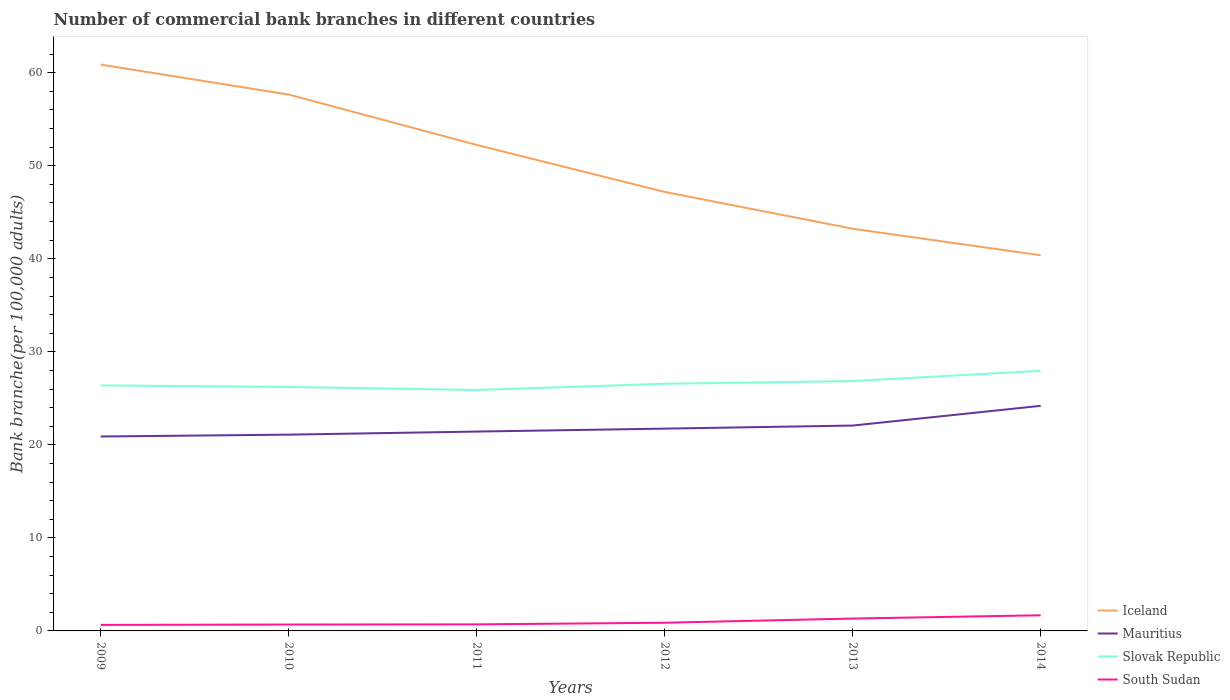How many different coloured lines are there?
Ensure brevity in your answer.  4. Does the line corresponding to Mauritius intersect with the line corresponding to Iceland?
Keep it short and to the point. No. Across all years, what is the maximum number of commercial bank branches in South Sudan?
Your answer should be very brief. 0.65. What is the total number of commercial bank branches in Iceland in the graph?
Ensure brevity in your answer.  2.85. What is the difference between the highest and the second highest number of commercial bank branches in Iceland?
Your answer should be compact. 20.5. What is the difference between the highest and the lowest number of commercial bank branches in South Sudan?
Provide a short and direct response. 2. How many lines are there?
Make the answer very short. 4. What is the difference between two consecutive major ticks on the Y-axis?
Provide a short and direct response. 10. Where does the legend appear in the graph?
Give a very brief answer. Bottom right. How many legend labels are there?
Give a very brief answer. 4. How are the legend labels stacked?
Your response must be concise. Vertical. What is the title of the graph?
Offer a terse response. Number of commercial bank branches in different countries. What is the label or title of the Y-axis?
Ensure brevity in your answer.  Bank branche(per 100,0 adults). What is the Bank branche(per 100,000 adults) in Iceland in 2009?
Keep it short and to the point. 60.87. What is the Bank branche(per 100,000 adults) of Mauritius in 2009?
Your answer should be compact. 20.9. What is the Bank branche(per 100,000 adults) of Slovak Republic in 2009?
Offer a very short reply. 26.39. What is the Bank branche(per 100,000 adults) in South Sudan in 2009?
Your response must be concise. 0.65. What is the Bank branche(per 100,000 adults) in Iceland in 2010?
Ensure brevity in your answer.  57.65. What is the Bank branche(per 100,000 adults) in Mauritius in 2010?
Your response must be concise. 21.1. What is the Bank branche(per 100,000 adults) of Slovak Republic in 2010?
Provide a succinct answer. 26.22. What is the Bank branche(per 100,000 adults) in South Sudan in 2010?
Provide a succinct answer. 0.69. What is the Bank branche(per 100,000 adults) of Iceland in 2011?
Give a very brief answer. 52.24. What is the Bank branche(per 100,000 adults) in Mauritius in 2011?
Provide a short and direct response. 21.43. What is the Bank branche(per 100,000 adults) in Slovak Republic in 2011?
Keep it short and to the point. 25.9. What is the Bank branche(per 100,000 adults) in South Sudan in 2011?
Provide a short and direct response. 0.7. What is the Bank branche(per 100,000 adults) in Iceland in 2012?
Offer a very short reply. 47.19. What is the Bank branche(per 100,000 adults) in Mauritius in 2012?
Your answer should be compact. 21.74. What is the Bank branche(per 100,000 adults) of Slovak Republic in 2012?
Give a very brief answer. 26.57. What is the Bank branche(per 100,000 adults) in South Sudan in 2012?
Provide a succinct answer. 0.88. What is the Bank branche(per 100,000 adults) in Iceland in 2013?
Provide a succinct answer. 43.23. What is the Bank branche(per 100,000 adults) in Mauritius in 2013?
Keep it short and to the point. 22.08. What is the Bank branche(per 100,000 adults) in Slovak Republic in 2013?
Your answer should be very brief. 26.86. What is the Bank branche(per 100,000 adults) in South Sudan in 2013?
Keep it short and to the point. 1.33. What is the Bank branche(per 100,000 adults) in Iceland in 2014?
Provide a short and direct response. 40.38. What is the Bank branche(per 100,000 adults) in Mauritius in 2014?
Provide a succinct answer. 24.19. What is the Bank branche(per 100,000 adults) in Slovak Republic in 2014?
Give a very brief answer. 27.96. What is the Bank branche(per 100,000 adults) in South Sudan in 2014?
Provide a succinct answer. 1.68. Across all years, what is the maximum Bank branche(per 100,000 adults) of Iceland?
Provide a succinct answer. 60.87. Across all years, what is the maximum Bank branche(per 100,000 adults) of Mauritius?
Provide a succinct answer. 24.19. Across all years, what is the maximum Bank branche(per 100,000 adults) in Slovak Republic?
Give a very brief answer. 27.96. Across all years, what is the maximum Bank branche(per 100,000 adults) in South Sudan?
Your answer should be very brief. 1.68. Across all years, what is the minimum Bank branche(per 100,000 adults) of Iceland?
Provide a short and direct response. 40.38. Across all years, what is the minimum Bank branche(per 100,000 adults) in Mauritius?
Keep it short and to the point. 20.9. Across all years, what is the minimum Bank branche(per 100,000 adults) of Slovak Republic?
Offer a very short reply. 25.9. Across all years, what is the minimum Bank branche(per 100,000 adults) of South Sudan?
Offer a very short reply. 0.65. What is the total Bank branche(per 100,000 adults) in Iceland in the graph?
Offer a very short reply. 301.57. What is the total Bank branche(per 100,000 adults) in Mauritius in the graph?
Make the answer very short. 131.44. What is the total Bank branche(per 100,000 adults) in Slovak Republic in the graph?
Provide a short and direct response. 159.89. What is the total Bank branche(per 100,000 adults) of South Sudan in the graph?
Keep it short and to the point. 5.93. What is the difference between the Bank branche(per 100,000 adults) in Iceland in 2009 and that in 2010?
Provide a succinct answer. 3.22. What is the difference between the Bank branche(per 100,000 adults) in Mauritius in 2009 and that in 2010?
Your answer should be very brief. -0.2. What is the difference between the Bank branche(per 100,000 adults) of Slovak Republic in 2009 and that in 2010?
Make the answer very short. 0.17. What is the difference between the Bank branche(per 100,000 adults) of South Sudan in 2009 and that in 2010?
Your response must be concise. -0.04. What is the difference between the Bank branche(per 100,000 adults) of Iceland in 2009 and that in 2011?
Provide a succinct answer. 8.63. What is the difference between the Bank branche(per 100,000 adults) of Mauritius in 2009 and that in 2011?
Your answer should be compact. -0.53. What is the difference between the Bank branche(per 100,000 adults) in Slovak Republic in 2009 and that in 2011?
Offer a very short reply. 0.49. What is the difference between the Bank branche(per 100,000 adults) of South Sudan in 2009 and that in 2011?
Your response must be concise. -0.06. What is the difference between the Bank branche(per 100,000 adults) in Iceland in 2009 and that in 2012?
Your answer should be compact. 13.69. What is the difference between the Bank branche(per 100,000 adults) in Mauritius in 2009 and that in 2012?
Ensure brevity in your answer.  -0.85. What is the difference between the Bank branche(per 100,000 adults) in Slovak Republic in 2009 and that in 2012?
Offer a terse response. -0.17. What is the difference between the Bank branche(per 100,000 adults) of South Sudan in 2009 and that in 2012?
Your answer should be very brief. -0.23. What is the difference between the Bank branche(per 100,000 adults) in Iceland in 2009 and that in 2013?
Make the answer very short. 17.64. What is the difference between the Bank branche(per 100,000 adults) of Mauritius in 2009 and that in 2013?
Provide a short and direct response. -1.18. What is the difference between the Bank branche(per 100,000 adults) in Slovak Republic in 2009 and that in 2013?
Your response must be concise. -0.46. What is the difference between the Bank branche(per 100,000 adults) of South Sudan in 2009 and that in 2013?
Make the answer very short. -0.68. What is the difference between the Bank branche(per 100,000 adults) of Iceland in 2009 and that in 2014?
Provide a short and direct response. 20.5. What is the difference between the Bank branche(per 100,000 adults) of Mauritius in 2009 and that in 2014?
Offer a terse response. -3.3. What is the difference between the Bank branche(per 100,000 adults) of Slovak Republic in 2009 and that in 2014?
Provide a succinct answer. -1.56. What is the difference between the Bank branche(per 100,000 adults) of South Sudan in 2009 and that in 2014?
Give a very brief answer. -1.04. What is the difference between the Bank branche(per 100,000 adults) in Iceland in 2010 and that in 2011?
Make the answer very short. 5.41. What is the difference between the Bank branche(per 100,000 adults) of Mauritius in 2010 and that in 2011?
Provide a short and direct response. -0.33. What is the difference between the Bank branche(per 100,000 adults) in Slovak Republic in 2010 and that in 2011?
Provide a short and direct response. 0.33. What is the difference between the Bank branche(per 100,000 adults) of South Sudan in 2010 and that in 2011?
Keep it short and to the point. -0.02. What is the difference between the Bank branche(per 100,000 adults) in Iceland in 2010 and that in 2012?
Ensure brevity in your answer.  10.46. What is the difference between the Bank branche(per 100,000 adults) of Mauritius in 2010 and that in 2012?
Your response must be concise. -0.65. What is the difference between the Bank branche(per 100,000 adults) in Slovak Republic in 2010 and that in 2012?
Your answer should be very brief. -0.34. What is the difference between the Bank branche(per 100,000 adults) in South Sudan in 2010 and that in 2012?
Offer a very short reply. -0.19. What is the difference between the Bank branche(per 100,000 adults) in Iceland in 2010 and that in 2013?
Your answer should be very brief. 14.42. What is the difference between the Bank branche(per 100,000 adults) of Mauritius in 2010 and that in 2013?
Keep it short and to the point. -0.98. What is the difference between the Bank branche(per 100,000 adults) in Slovak Republic in 2010 and that in 2013?
Give a very brief answer. -0.63. What is the difference between the Bank branche(per 100,000 adults) in South Sudan in 2010 and that in 2013?
Offer a very short reply. -0.64. What is the difference between the Bank branche(per 100,000 adults) in Iceland in 2010 and that in 2014?
Ensure brevity in your answer.  17.27. What is the difference between the Bank branche(per 100,000 adults) in Mauritius in 2010 and that in 2014?
Your answer should be compact. -3.1. What is the difference between the Bank branche(per 100,000 adults) in Slovak Republic in 2010 and that in 2014?
Give a very brief answer. -1.73. What is the difference between the Bank branche(per 100,000 adults) in South Sudan in 2010 and that in 2014?
Your answer should be very brief. -1. What is the difference between the Bank branche(per 100,000 adults) in Iceland in 2011 and that in 2012?
Offer a terse response. 5.05. What is the difference between the Bank branche(per 100,000 adults) in Mauritius in 2011 and that in 2012?
Your answer should be compact. -0.32. What is the difference between the Bank branche(per 100,000 adults) of Slovak Republic in 2011 and that in 2012?
Make the answer very short. -0.67. What is the difference between the Bank branche(per 100,000 adults) in South Sudan in 2011 and that in 2012?
Provide a succinct answer. -0.17. What is the difference between the Bank branche(per 100,000 adults) in Iceland in 2011 and that in 2013?
Give a very brief answer. 9.01. What is the difference between the Bank branche(per 100,000 adults) of Mauritius in 2011 and that in 2013?
Provide a succinct answer. -0.65. What is the difference between the Bank branche(per 100,000 adults) of Slovak Republic in 2011 and that in 2013?
Offer a very short reply. -0.96. What is the difference between the Bank branche(per 100,000 adults) of South Sudan in 2011 and that in 2013?
Your response must be concise. -0.63. What is the difference between the Bank branche(per 100,000 adults) of Iceland in 2011 and that in 2014?
Your answer should be very brief. 11.86. What is the difference between the Bank branche(per 100,000 adults) in Mauritius in 2011 and that in 2014?
Ensure brevity in your answer.  -2.76. What is the difference between the Bank branche(per 100,000 adults) in Slovak Republic in 2011 and that in 2014?
Offer a very short reply. -2.06. What is the difference between the Bank branche(per 100,000 adults) of South Sudan in 2011 and that in 2014?
Make the answer very short. -0.98. What is the difference between the Bank branche(per 100,000 adults) in Iceland in 2012 and that in 2013?
Provide a succinct answer. 3.96. What is the difference between the Bank branche(per 100,000 adults) of Mauritius in 2012 and that in 2013?
Your response must be concise. -0.33. What is the difference between the Bank branche(per 100,000 adults) in Slovak Republic in 2012 and that in 2013?
Give a very brief answer. -0.29. What is the difference between the Bank branche(per 100,000 adults) in South Sudan in 2012 and that in 2013?
Provide a succinct answer. -0.45. What is the difference between the Bank branche(per 100,000 adults) of Iceland in 2012 and that in 2014?
Offer a terse response. 6.81. What is the difference between the Bank branche(per 100,000 adults) in Mauritius in 2012 and that in 2014?
Offer a terse response. -2.45. What is the difference between the Bank branche(per 100,000 adults) in Slovak Republic in 2012 and that in 2014?
Your answer should be compact. -1.39. What is the difference between the Bank branche(per 100,000 adults) of South Sudan in 2012 and that in 2014?
Offer a very short reply. -0.8. What is the difference between the Bank branche(per 100,000 adults) in Iceland in 2013 and that in 2014?
Keep it short and to the point. 2.85. What is the difference between the Bank branche(per 100,000 adults) of Mauritius in 2013 and that in 2014?
Your answer should be compact. -2.12. What is the difference between the Bank branche(per 100,000 adults) of Slovak Republic in 2013 and that in 2014?
Offer a very short reply. -1.1. What is the difference between the Bank branche(per 100,000 adults) in South Sudan in 2013 and that in 2014?
Your answer should be compact. -0.35. What is the difference between the Bank branche(per 100,000 adults) in Iceland in 2009 and the Bank branche(per 100,000 adults) in Mauritius in 2010?
Offer a very short reply. 39.78. What is the difference between the Bank branche(per 100,000 adults) of Iceland in 2009 and the Bank branche(per 100,000 adults) of Slovak Republic in 2010?
Your answer should be very brief. 34.65. What is the difference between the Bank branche(per 100,000 adults) in Iceland in 2009 and the Bank branche(per 100,000 adults) in South Sudan in 2010?
Give a very brief answer. 60.19. What is the difference between the Bank branche(per 100,000 adults) in Mauritius in 2009 and the Bank branche(per 100,000 adults) in Slovak Republic in 2010?
Make the answer very short. -5.33. What is the difference between the Bank branche(per 100,000 adults) in Mauritius in 2009 and the Bank branche(per 100,000 adults) in South Sudan in 2010?
Offer a very short reply. 20.21. What is the difference between the Bank branche(per 100,000 adults) in Slovak Republic in 2009 and the Bank branche(per 100,000 adults) in South Sudan in 2010?
Offer a very short reply. 25.71. What is the difference between the Bank branche(per 100,000 adults) in Iceland in 2009 and the Bank branche(per 100,000 adults) in Mauritius in 2011?
Give a very brief answer. 39.45. What is the difference between the Bank branche(per 100,000 adults) of Iceland in 2009 and the Bank branche(per 100,000 adults) of Slovak Republic in 2011?
Your answer should be compact. 34.98. What is the difference between the Bank branche(per 100,000 adults) of Iceland in 2009 and the Bank branche(per 100,000 adults) of South Sudan in 2011?
Provide a succinct answer. 60.17. What is the difference between the Bank branche(per 100,000 adults) of Mauritius in 2009 and the Bank branche(per 100,000 adults) of Slovak Republic in 2011?
Offer a terse response. -5. What is the difference between the Bank branche(per 100,000 adults) of Mauritius in 2009 and the Bank branche(per 100,000 adults) of South Sudan in 2011?
Make the answer very short. 20.19. What is the difference between the Bank branche(per 100,000 adults) of Slovak Republic in 2009 and the Bank branche(per 100,000 adults) of South Sudan in 2011?
Make the answer very short. 25.69. What is the difference between the Bank branche(per 100,000 adults) of Iceland in 2009 and the Bank branche(per 100,000 adults) of Mauritius in 2012?
Give a very brief answer. 39.13. What is the difference between the Bank branche(per 100,000 adults) in Iceland in 2009 and the Bank branche(per 100,000 adults) in Slovak Republic in 2012?
Ensure brevity in your answer.  34.31. What is the difference between the Bank branche(per 100,000 adults) in Iceland in 2009 and the Bank branche(per 100,000 adults) in South Sudan in 2012?
Offer a very short reply. 60. What is the difference between the Bank branche(per 100,000 adults) of Mauritius in 2009 and the Bank branche(per 100,000 adults) of Slovak Republic in 2012?
Ensure brevity in your answer.  -5.67. What is the difference between the Bank branche(per 100,000 adults) of Mauritius in 2009 and the Bank branche(per 100,000 adults) of South Sudan in 2012?
Keep it short and to the point. 20.02. What is the difference between the Bank branche(per 100,000 adults) in Slovak Republic in 2009 and the Bank branche(per 100,000 adults) in South Sudan in 2012?
Give a very brief answer. 25.51. What is the difference between the Bank branche(per 100,000 adults) in Iceland in 2009 and the Bank branche(per 100,000 adults) in Mauritius in 2013?
Your response must be concise. 38.8. What is the difference between the Bank branche(per 100,000 adults) of Iceland in 2009 and the Bank branche(per 100,000 adults) of Slovak Republic in 2013?
Ensure brevity in your answer.  34.02. What is the difference between the Bank branche(per 100,000 adults) in Iceland in 2009 and the Bank branche(per 100,000 adults) in South Sudan in 2013?
Provide a short and direct response. 59.54. What is the difference between the Bank branche(per 100,000 adults) in Mauritius in 2009 and the Bank branche(per 100,000 adults) in Slovak Republic in 2013?
Offer a terse response. -5.96. What is the difference between the Bank branche(per 100,000 adults) of Mauritius in 2009 and the Bank branche(per 100,000 adults) of South Sudan in 2013?
Your answer should be compact. 19.57. What is the difference between the Bank branche(per 100,000 adults) of Slovak Republic in 2009 and the Bank branche(per 100,000 adults) of South Sudan in 2013?
Make the answer very short. 25.06. What is the difference between the Bank branche(per 100,000 adults) of Iceland in 2009 and the Bank branche(per 100,000 adults) of Mauritius in 2014?
Ensure brevity in your answer.  36.68. What is the difference between the Bank branche(per 100,000 adults) in Iceland in 2009 and the Bank branche(per 100,000 adults) in Slovak Republic in 2014?
Provide a succinct answer. 32.92. What is the difference between the Bank branche(per 100,000 adults) of Iceland in 2009 and the Bank branche(per 100,000 adults) of South Sudan in 2014?
Make the answer very short. 59.19. What is the difference between the Bank branche(per 100,000 adults) in Mauritius in 2009 and the Bank branche(per 100,000 adults) in Slovak Republic in 2014?
Your response must be concise. -7.06. What is the difference between the Bank branche(per 100,000 adults) in Mauritius in 2009 and the Bank branche(per 100,000 adults) in South Sudan in 2014?
Make the answer very short. 19.21. What is the difference between the Bank branche(per 100,000 adults) in Slovak Republic in 2009 and the Bank branche(per 100,000 adults) in South Sudan in 2014?
Give a very brief answer. 24.71. What is the difference between the Bank branche(per 100,000 adults) of Iceland in 2010 and the Bank branche(per 100,000 adults) of Mauritius in 2011?
Offer a terse response. 36.22. What is the difference between the Bank branche(per 100,000 adults) in Iceland in 2010 and the Bank branche(per 100,000 adults) in Slovak Republic in 2011?
Provide a succinct answer. 31.75. What is the difference between the Bank branche(per 100,000 adults) in Iceland in 2010 and the Bank branche(per 100,000 adults) in South Sudan in 2011?
Make the answer very short. 56.95. What is the difference between the Bank branche(per 100,000 adults) of Mauritius in 2010 and the Bank branche(per 100,000 adults) of Slovak Republic in 2011?
Give a very brief answer. -4.8. What is the difference between the Bank branche(per 100,000 adults) in Mauritius in 2010 and the Bank branche(per 100,000 adults) in South Sudan in 2011?
Give a very brief answer. 20.39. What is the difference between the Bank branche(per 100,000 adults) of Slovak Republic in 2010 and the Bank branche(per 100,000 adults) of South Sudan in 2011?
Your response must be concise. 25.52. What is the difference between the Bank branche(per 100,000 adults) in Iceland in 2010 and the Bank branche(per 100,000 adults) in Mauritius in 2012?
Keep it short and to the point. 35.91. What is the difference between the Bank branche(per 100,000 adults) of Iceland in 2010 and the Bank branche(per 100,000 adults) of Slovak Republic in 2012?
Provide a succinct answer. 31.09. What is the difference between the Bank branche(per 100,000 adults) in Iceland in 2010 and the Bank branche(per 100,000 adults) in South Sudan in 2012?
Give a very brief answer. 56.77. What is the difference between the Bank branche(per 100,000 adults) in Mauritius in 2010 and the Bank branche(per 100,000 adults) in Slovak Republic in 2012?
Ensure brevity in your answer.  -5.47. What is the difference between the Bank branche(per 100,000 adults) in Mauritius in 2010 and the Bank branche(per 100,000 adults) in South Sudan in 2012?
Offer a terse response. 20.22. What is the difference between the Bank branche(per 100,000 adults) in Slovak Republic in 2010 and the Bank branche(per 100,000 adults) in South Sudan in 2012?
Keep it short and to the point. 25.35. What is the difference between the Bank branche(per 100,000 adults) of Iceland in 2010 and the Bank branche(per 100,000 adults) of Mauritius in 2013?
Provide a short and direct response. 35.58. What is the difference between the Bank branche(per 100,000 adults) in Iceland in 2010 and the Bank branche(per 100,000 adults) in Slovak Republic in 2013?
Provide a short and direct response. 30.8. What is the difference between the Bank branche(per 100,000 adults) of Iceland in 2010 and the Bank branche(per 100,000 adults) of South Sudan in 2013?
Your response must be concise. 56.32. What is the difference between the Bank branche(per 100,000 adults) of Mauritius in 2010 and the Bank branche(per 100,000 adults) of Slovak Republic in 2013?
Make the answer very short. -5.76. What is the difference between the Bank branche(per 100,000 adults) in Mauritius in 2010 and the Bank branche(per 100,000 adults) in South Sudan in 2013?
Keep it short and to the point. 19.77. What is the difference between the Bank branche(per 100,000 adults) of Slovak Republic in 2010 and the Bank branche(per 100,000 adults) of South Sudan in 2013?
Offer a very short reply. 24.89. What is the difference between the Bank branche(per 100,000 adults) in Iceland in 2010 and the Bank branche(per 100,000 adults) in Mauritius in 2014?
Give a very brief answer. 33.46. What is the difference between the Bank branche(per 100,000 adults) in Iceland in 2010 and the Bank branche(per 100,000 adults) in Slovak Republic in 2014?
Keep it short and to the point. 29.7. What is the difference between the Bank branche(per 100,000 adults) in Iceland in 2010 and the Bank branche(per 100,000 adults) in South Sudan in 2014?
Provide a short and direct response. 55.97. What is the difference between the Bank branche(per 100,000 adults) of Mauritius in 2010 and the Bank branche(per 100,000 adults) of Slovak Republic in 2014?
Give a very brief answer. -6.86. What is the difference between the Bank branche(per 100,000 adults) in Mauritius in 2010 and the Bank branche(per 100,000 adults) in South Sudan in 2014?
Provide a short and direct response. 19.42. What is the difference between the Bank branche(per 100,000 adults) of Slovak Republic in 2010 and the Bank branche(per 100,000 adults) of South Sudan in 2014?
Provide a succinct answer. 24.54. What is the difference between the Bank branche(per 100,000 adults) of Iceland in 2011 and the Bank branche(per 100,000 adults) of Mauritius in 2012?
Offer a terse response. 30.5. What is the difference between the Bank branche(per 100,000 adults) in Iceland in 2011 and the Bank branche(per 100,000 adults) in Slovak Republic in 2012?
Your answer should be compact. 25.68. What is the difference between the Bank branche(per 100,000 adults) of Iceland in 2011 and the Bank branche(per 100,000 adults) of South Sudan in 2012?
Your answer should be compact. 51.36. What is the difference between the Bank branche(per 100,000 adults) of Mauritius in 2011 and the Bank branche(per 100,000 adults) of Slovak Republic in 2012?
Provide a short and direct response. -5.14. What is the difference between the Bank branche(per 100,000 adults) of Mauritius in 2011 and the Bank branche(per 100,000 adults) of South Sudan in 2012?
Keep it short and to the point. 20.55. What is the difference between the Bank branche(per 100,000 adults) in Slovak Republic in 2011 and the Bank branche(per 100,000 adults) in South Sudan in 2012?
Your answer should be compact. 25.02. What is the difference between the Bank branche(per 100,000 adults) in Iceland in 2011 and the Bank branche(per 100,000 adults) in Mauritius in 2013?
Give a very brief answer. 30.17. What is the difference between the Bank branche(per 100,000 adults) in Iceland in 2011 and the Bank branche(per 100,000 adults) in Slovak Republic in 2013?
Make the answer very short. 25.38. What is the difference between the Bank branche(per 100,000 adults) of Iceland in 2011 and the Bank branche(per 100,000 adults) of South Sudan in 2013?
Provide a short and direct response. 50.91. What is the difference between the Bank branche(per 100,000 adults) of Mauritius in 2011 and the Bank branche(per 100,000 adults) of Slovak Republic in 2013?
Your answer should be compact. -5.43. What is the difference between the Bank branche(per 100,000 adults) of Mauritius in 2011 and the Bank branche(per 100,000 adults) of South Sudan in 2013?
Ensure brevity in your answer.  20.1. What is the difference between the Bank branche(per 100,000 adults) of Slovak Republic in 2011 and the Bank branche(per 100,000 adults) of South Sudan in 2013?
Your response must be concise. 24.57. What is the difference between the Bank branche(per 100,000 adults) in Iceland in 2011 and the Bank branche(per 100,000 adults) in Mauritius in 2014?
Your answer should be compact. 28.05. What is the difference between the Bank branche(per 100,000 adults) of Iceland in 2011 and the Bank branche(per 100,000 adults) of Slovak Republic in 2014?
Give a very brief answer. 24.28. What is the difference between the Bank branche(per 100,000 adults) in Iceland in 2011 and the Bank branche(per 100,000 adults) in South Sudan in 2014?
Make the answer very short. 50.56. What is the difference between the Bank branche(per 100,000 adults) of Mauritius in 2011 and the Bank branche(per 100,000 adults) of Slovak Republic in 2014?
Offer a very short reply. -6.53. What is the difference between the Bank branche(per 100,000 adults) of Mauritius in 2011 and the Bank branche(per 100,000 adults) of South Sudan in 2014?
Give a very brief answer. 19.75. What is the difference between the Bank branche(per 100,000 adults) in Slovak Republic in 2011 and the Bank branche(per 100,000 adults) in South Sudan in 2014?
Your response must be concise. 24.21. What is the difference between the Bank branche(per 100,000 adults) of Iceland in 2012 and the Bank branche(per 100,000 adults) of Mauritius in 2013?
Provide a short and direct response. 25.11. What is the difference between the Bank branche(per 100,000 adults) in Iceland in 2012 and the Bank branche(per 100,000 adults) in Slovak Republic in 2013?
Provide a short and direct response. 20.33. What is the difference between the Bank branche(per 100,000 adults) in Iceland in 2012 and the Bank branche(per 100,000 adults) in South Sudan in 2013?
Your answer should be very brief. 45.86. What is the difference between the Bank branche(per 100,000 adults) of Mauritius in 2012 and the Bank branche(per 100,000 adults) of Slovak Republic in 2013?
Offer a very short reply. -5.11. What is the difference between the Bank branche(per 100,000 adults) of Mauritius in 2012 and the Bank branche(per 100,000 adults) of South Sudan in 2013?
Your response must be concise. 20.41. What is the difference between the Bank branche(per 100,000 adults) of Slovak Republic in 2012 and the Bank branche(per 100,000 adults) of South Sudan in 2013?
Your response must be concise. 25.23. What is the difference between the Bank branche(per 100,000 adults) of Iceland in 2012 and the Bank branche(per 100,000 adults) of Mauritius in 2014?
Your answer should be compact. 22.99. What is the difference between the Bank branche(per 100,000 adults) in Iceland in 2012 and the Bank branche(per 100,000 adults) in Slovak Republic in 2014?
Make the answer very short. 19.23. What is the difference between the Bank branche(per 100,000 adults) in Iceland in 2012 and the Bank branche(per 100,000 adults) in South Sudan in 2014?
Provide a succinct answer. 45.5. What is the difference between the Bank branche(per 100,000 adults) in Mauritius in 2012 and the Bank branche(per 100,000 adults) in Slovak Republic in 2014?
Your answer should be very brief. -6.21. What is the difference between the Bank branche(per 100,000 adults) of Mauritius in 2012 and the Bank branche(per 100,000 adults) of South Sudan in 2014?
Offer a very short reply. 20.06. What is the difference between the Bank branche(per 100,000 adults) of Slovak Republic in 2012 and the Bank branche(per 100,000 adults) of South Sudan in 2014?
Offer a terse response. 24.88. What is the difference between the Bank branche(per 100,000 adults) in Iceland in 2013 and the Bank branche(per 100,000 adults) in Mauritius in 2014?
Provide a succinct answer. 19.04. What is the difference between the Bank branche(per 100,000 adults) in Iceland in 2013 and the Bank branche(per 100,000 adults) in Slovak Republic in 2014?
Keep it short and to the point. 15.27. What is the difference between the Bank branche(per 100,000 adults) of Iceland in 2013 and the Bank branche(per 100,000 adults) of South Sudan in 2014?
Your response must be concise. 41.55. What is the difference between the Bank branche(per 100,000 adults) of Mauritius in 2013 and the Bank branche(per 100,000 adults) of Slovak Republic in 2014?
Offer a terse response. -5.88. What is the difference between the Bank branche(per 100,000 adults) of Mauritius in 2013 and the Bank branche(per 100,000 adults) of South Sudan in 2014?
Offer a very short reply. 20.39. What is the difference between the Bank branche(per 100,000 adults) of Slovak Republic in 2013 and the Bank branche(per 100,000 adults) of South Sudan in 2014?
Give a very brief answer. 25.17. What is the average Bank branche(per 100,000 adults) of Iceland per year?
Your answer should be compact. 50.26. What is the average Bank branche(per 100,000 adults) in Mauritius per year?
Give a very brief answer. 21.91. What is the average Bank branche(per 100,000 adults) in Slovak Republic per year?
Give a very brief answer. 26.65. What is the average Bank branche(per 100,000 adults) in South Sudan per year?
Make the answer very short. 0.99. In the year 2009, what is the difference between the Bank branche(per 100,000 adults) of Iceland and Bank branche(per 100,000 adults) of Mauritius?
Your answer should be very brief. 39.98. In the year 2009, what is the difference between the Bank branche(per 100,000 adults) in Iceland and Bank branche(per 100,000 adults) in Slovak Republic?
Your response must be concise. 34.48. In the year 2009, what is the difference between the Bank branche(per 100,000 adults) in Iceland and Bank branche(per 100,000 adults) in South Sudan?
Provide a succinct answer. 60.23. In the year 2009, what is the difference between the Bank branche(per 100,000 adults) of Mauritius and Bank branche(per 100,000 adults) of Slovak Republic?
Your response must be concise. -5.49. In the year 2009, what is the difference between the Bank branche(per 100,000 adults) in Mauritius and Bank branche(per 100,000 adults) in South Sudan?
Your response must be concise. 20.25. In the year 2009, what is the difference between the Bank branche(per 100,000 adults) of Slovak Republic and Bank branche(per 100,000 adults) of South Sudan?
Provide a short and direct response. 25.75. In the year 2010, what is the difference between the Bank branche(per 100,000 adults) of Iceland and Bank branche(per 100,000 adults) of Mauritius?
Ensure brevity in your answer.  36.55. In the year 2010, what is the difference between the Bank branche(per 100,000 adults) in Iceland and Bank branche(per 100,000 adults) in Slovak Republic?
Make the answer very short. 31.43. In the year 2010, what is the difference between the Bank branche(per 100,000 adults) of Iceland and Bank branche(per 100,000 adults) of South Sudan?
Your response must be concise. 56.97. In the year 2010, what is the difference between the Bank branche(per 100,000 adults) in Mauritius and Bank branche(per 100,000 adults) in Slovak Republic?
Provide a succinct answer. -5.13. In the year 2010, what is the difference between the Bank branche(per 100,000 adults) of Mauritius and Bank branche(per 100,000 adults) of South Sudan?
Provide a short and direct response. 20.41. In the year 2010, what is the difference between the Bank branche(per 100,000 adults) of Slovak Republic and Bank branche(per 100,000 adults) of South Sudan?
Offer a very short reply. 25.54. In the year 2011, what is the difference between the Bank branche(per 100,000 adults) in Iceland and Bank branche(per 100,000 adults) in Mauritius?
Your response must be concise. 30.81. In the year 2011, what is the difference between the Bank branche(per 100,000 adults) in Iceland and Bank branche(per 100,000 adults) in Slovak Republic?
Provide a short and direct response. 26.34. In the year 2011, what is the difference between the Bank branche(per 100,000 adults) in Iceland and Bank branche(per 100,000 adults) in South Sudan?
Your response must be concise. 51.54. In the year 2011, what is the difference between the Bank branche(per 100,000 adults) in Mauritius and Bank branche(per 100,000 adults) in Slovak Republic?
Your answer should be very brief. -4.47. In the year 2011, what is the difference between the Bank branche(per 100,000 adults) of Mauritius and Bank branche(per 100,000 adults) of South Sudan?
Your response must be concise. 20.73. In the year 2011, what is the difference between the Bank branche(per 100,000 adults) of Slovak Republic and Bank branche(per 100,000 adults) of South Sudan?
Keep it short and to the point. 25.19. In the year 2012, what is the difference between the Bank branche(per 100,000 adults) of Iceland and Bank branche(per 100,000 adults) of Mauritius?
Provide a succinct answer. 25.44. In the year 2012, what is the difference between the Bank branche(per 100,000 adults) of Iceland and Bank branche(per 100,000 adults) of Slovak Republic?
Ensure brevity in your answer.  20.62. In the year 2012, what is the difference between the Bank branche(per 100,000 adults) of Iceland and Bank branche(per 100,000 adults) of South Sudan?
Make the answer very short. 46.31. In the year 2012, what is the difference between the Bank branche(per 100,000 adults) in Mauritius and Bank branche(per 100,000 adults) in Slovak Republic?
Your answer should be compact. -4.82. In the year 2012, what is the difference between the Bank branche(per 100,000 adults) of Mauritius and Bank branche(per 100,000 adults) of South Sudan?
Make the answer very short. 20.87. In the year 2012, what is the difference between the Bank branche(per 100,000 adults) in Slovak Republic and Bank branche(per 100,000 adults) in South Sudan?
Give a very brief answer. 25.69. In the year 2013, what is the difference between the Bank branche(per 100,000 adults) of Iceland and Bank branche(per 100,000 adults) of Mauritius?
Keep it short and to the point. 21.16. In the year 2013, what is the difference between the Bank branche(per 100,000 adults) in Iceland and Bank branche(per 100,000 adults) in Slovak Republic?
Ensure brevity in your answer.  16.37. In the year 2013, what is the difference between the Bank branche(per 100,000 adults) of Iceland and Bank branche(per 100,000 adults) of South Sudan?
Your response must be concise. 41.9. In the year 2013, what is the difference between the Bank branche(per 100,000 adults) in Mauritius and Bank branche(per 100,000 adults) in Slovak Republic?
Your response must be concise. -4.78. In the year 2013, what is the difference between the Bank branche(per 100,000 adults) in Mauritius and Bank branche(per 100,000 adults) in South Sudan?
Your answer should be compact. 20.74. In the year 2013, what is the difference between the Bank branche(per 100,000 adults) in Slovak Republic and Bank branche(per 100,000 adults) in South Sudan?
Provide a short and direct response. 25.53. In the year 2014, what is the difference between the Bank branche(per 100,000 adults) in Iceland and Bank branche(per 100,000 adults) in Mauritius?
Offer a very short reply. 16.18. In the year 2014, what is the difference between the Bank branche(per 100,000 adults) in Iceland and Bank branche(per 100,000 adults) in Slovak Republic?
Keep it short and to the point. 12.42. In the year 2014, what is the difference between the Bank branche(per 100,000 adults) in Iceland and Bank branche(per 100,000 adults) in South Sudan?
Give a very brief answer. 38.7. In the year 2014, what is the difference between the Bank branche(per 100,000 adults) of Mauritius and Bank branche(per 100,000 adults) of Slovak Republic?
Offer a very short reply. -3.76. In the year 2014, what is the difference between the Bank branche(per 100,000 adults) in Mauritius and Bank branche(per 100,000 adults) in South Sudan?
Your response must be concise. 22.51. In the year 2014, what is the difference between the Bank branche(per 100,000 adults) in Slovak Republic and Bank branche(per 100,000 adults) in South Sudan?
Offer a terse response. 26.27. What is the ratio of the Bank branche(per 100,000 adults) of Iceland in 2009 to that in 2010?
Keep it short and to the point. 1.06. What is the ratio of the Bank branche(per 100,000 adults) in Slovak Republic in 2009 to that in 2010?
Provide a succinct answer. 1.01. What is the ratio of the Bank branche(per 100,000 adults) of South Sudan in 2009 to that in 2010?
Make the answer very short. 0.94. What is the ratio of the Bank branche(per 100,000 adults) of Iceland in 2009 to that in 2011?
Offer a very short reply. 1.17. What is the ratio of the Bank branche(per 100,000 adults) of Mauritius in 2009 to that in 2011?
Offer a very short reply. 0.98. What is the ratio of the Bank branche(per 100,000 adults) in Slovak Republic in 2009 to that in 2011?
Keep it short and to the point. 1.02. What is the ratio of the Bank branche(per 100,000 adults) in South Sudan in 2009 to that in 2011?
Provide a short and direct response. 0.92. What is the ratio of the Bank branche(per 100,000 adults) in Iceland in 2009 to that in 2012?
Offer a terse response. 1.29. What is the ratio of the Bank branche(per 100,000 adults) in Mauritius in 2009 to that in 2012?
Keep it short and to the point. 0.96. What is the ratio of the Bank branche(per 100,000 adults) of Slovak Republic in 2009 to that in 2012?
Your answer should be very brief. 0.99. What is the ratio of the Bank branche(per 100,000 adults) of South Sudan in 2009 to that in 2012?
Provide a succinct answer. 0.73. What is the ratio of the Bank branche(per 100,000 adults) in Iceland in 2009 to that in 2013?
Your response must be concise. 1.41. What is the ratio of the Bank branche(per 100,000 adults) in Mauritius in 2009 to that in 2013?
Make the answer very short. 0.95. What is the ratio of the Bank branche(per 100,000 adults) in Slovak Republic in 2009 to that in 2013?
Your answer should be very brief. 0.98. What is the ratio of the Bank branche(per 100,000 adults) of South Sudan in 2009 to that in 2013?
Your response must be concise. 0.49. What is the ratio of the Bank branche(per 100,000 adults) of Iceland in 2009 to that in 2014?
Provide a short and direct response. 1.51. What is the ratio of the Bank branche(per 100,000 adults) of Mauritius in 2009 to that in 2014?
Your response must be concise. 0.86. What is the ratio of the Bank branche(per 100,000 adults) of Slovak Republic in 2009 to that in 2014?
Your response must be concise. 0.94. What is the ratio of the Bank branche(per 100,000 adults) in South Sudan in 2009 to that in 2014?
Your answer should be very brief. 0.38. What is the ratio of the Bank branche(per 100,000 adults) of Iceland in 2010 to that in 2011?
Offer a terse response. 1.1. What is the ratio of the Bank branche(per 100,000 adults) of Mauritius in 2010 to that in 2011?
Give a very brief answer. 0.98. What is the ratio of the Bank branche(per 100,000 adults) of Slovak Republic in 2010 to that in 2011?
Your answer should be compact. 1.01. What is the ratio of the Bank branche(per 100,000 adults) in South Sudan in 2010 to that in 2011?
Your answer should be compact. 0.97. What is the ratio of the Bank branche(per 100,000 adults) of Iceland in 2010 to that in 2012?
Offer a very short reply. 1.22. What is the ratio of the Bank branche(per 100,000 adults) in Mauritius in 2010 to that in 2012?
Your answer should be compact. 0.97. What is the ratio of the Bank branche(per 100,000 adults) in Slovak Republic in 2010 to that in 2012?
Make the answer very short. 0.99. What is the ratio of the Bank branche(per 100,000 adults) in South Sudan in 2010 to that in 2012?
Keep it short and to the point. 0.78. What is the ratio of the Bank branche(per 100,000 adults) of Iceland in 2010 to that in 2013?
Your answer should be compact. 1.33. What is the ratio of the Bank branche(per 100,000 adults) of Mauritius in 2010 to that in 2013?
Your answer should be compact. 0.96. What is the ratio of the Bank branche(per 100,000 adults) in Slovak Republic in 2010 to that in 2013?
Provide a short and direct response. 0.98. What is the ratio of the Bank branche(per 100,000 adults) of South Sudan in 2010 to that in 2013?
Ensure brevity in your answer.  0.52. What is the ratio of the Bank branche(per 100,000 adults) in Iceland in 2010 to that in 2014?
Your answer should be very brief. 1.43. What is the ratio of the Bank branche(per 100,000 adults) in Mauritius in 2010 to that in 2014?
Your response must be concise. 0.87. What is the ratio of the Bank branche(per 100,000 adults) in Slovak Republic in 2010 to that in 2014?
Give a very brief answer. 0.94. What is the ratio of the Bank branche(per 100,000 adults) of South Sudan in 2010 to that in 2014?
Your answer should be very brief. 0.41. What is the ratio of the Bank branche(per 100,000 adults) in Iceland in 2011 to that in 2012?
Your response must be concise. 1.11. What is the ratio of the Bank branche(per 100,000 adults) of Mauritius in 2011 to that in 2012?
Your answer should be very brief. 0.99. What is the ratio of the Bank branche(per 100,000 adults) of Slovak Republic in 2011 to that in 2012?
Your response must be concise. 0.97. What is the ratio of the Bank branche(per 100,000 adults) of South Sudan in 2011 to that in 2012?
Your answer should be very brief. 0.8. What is the ratio of the Bank branche(per 100,000 adults) in Iceland in 2011 to that in 2013?
Your answer should be very brief. 1.21. What is the ratio of the Bank branche(per 100,000 adults) of Mauritius in 2011 to that in 2013?
Offer a very short reply. 0.97. What is the ratio of the Bank branche(per 100,000 adults) in Slovak Republic in 2011 to that in 2013?
Offer a terse response. 0.96. What is the ratio of the Bank branche(per 100,000 adults) in South Sudan in 2011 to that in 2013?
Ensure brevity in your answer.  0.53. What is the ratio of the Bank branche(per 100,000 adults) of Iceland in 2011 to that in 2014?
Keep it short and to the point. 1.29. What is the ratio of the Bank branche(per 100,000 adults) of Mauritius in 2011 to that in 2014?
Keep it short and to the point. 0.89. What is the ratio of the Bank branche(per 100,000 adults) in Slovak Republic in 2011 to that in 2014?
Offer a very short reply. 0.93. What is the ratio of the Bank branche(per 100,000 adults) in South Sudan in 2011 to that in 2014?
Offer a terse response. 0.42. What is the ratio of the Bank branche(per 100,000 adults) of Iceland in 2012 to that in 2013?
Your response must be concise. 1.09. What is the ratio of the Bank branche(per 100,000 adults) in Mauritius in 2012 to that in 2013?
Your response must be concise. 0.98. What is the ratio of the Bank branche(per 100,000 adults) of Slovak Republic in 2012 to that in 2013?
Provide a succinct answer. 0.99. What is the ratio of the Bank branche(per 100,000 adults) of South Sudan in 2012 to that in 2013?
Your answer should be compact. 0.66. What is the ratio of the Bank branche(per 100,000 adults) in Iceland in 2012 to that in 2014?
Keep it short and to the point. 1.17. What is the ratio of the Bank branche(per 100,000 adults) of Mauritius in 2012 to that in 2014?
Your response must be concise. 0.9. What is the ratio of the Bank branche(per 100,000 adults) of Slovak Republic in 2012 to that in 2014?
Provide a succinct answer. 0.95. What is the ratio of the Bank branche(per 100,000 adults) in South Sudan in 2012 to that in 2014?
Provide a short and direct response. 0.52. What is the ratio of the Bank branche(per 100,000 adults) of Iceland in 2013 to that in 2014?
Your answer should be compact. 1.07. What is the ratio of the Bank branche(per 100,000 adults) in Mauritius in 2013 to that in 2014?
Keep it short and to the point. 0.91. What is the ratio of the Bank branche(per 100,000 adults) of Slovak Republic in 2013 to that in 2014?
Provide a short and direct response. 0.96. What is the ratio of the Bank branche(per 100,000 adults) of South Sudan in 2013 to that in 2014?
Provide a short and direct response. 0.79. What is the difference between the highest and the second highest Bank branche(per 100,000 adults) of Iceland?
Offer a terse response. 3.22. What is the difference between the highest and the second highest Bank branche(per 100,000 adults) in Mauritius?
Offer a very short reply. 2.12. What is the difference between the highest and the second highest Bank branche(per 100,000 adults) in Slovak Republic?
Your response must be concise. 1.1. What is the difference between the highest and the second highest Bank branche(per 100,000 adults) of South Sudan?
Your answer should be compact. 0.35. What is the difference between the highest and the lowest Bank branche(per 100,000 adults) of Iceland?
Provide a succinct answer. 20.5. What is the difference between the highest and the lowest Bank branche(per 100,000 adults) in Mauritius?
Your answer should be compact. 3.3. What is the difference between the highest and the lowest Bank branche(per 100,000 adults) in Slovak Republic?
Provide a succinct answer. 2.06. What is the difference between the highest and the lowest Bank branche(per 100,000 adults) in South Sudan?
Ensure brevity in your answer.  1.04. 